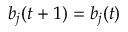Convert formula to latex. <formula><loc_0><loc_0><loc_500><loc_500>b _ { j } ( t + 1 ) = b _ { j } ( t )</formula> 